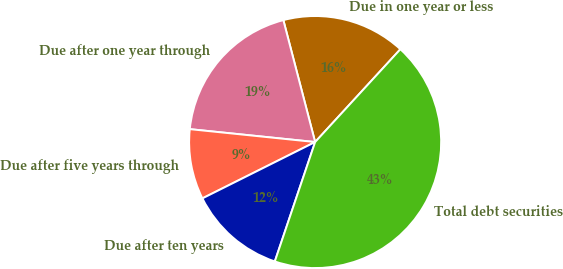Convert chart. <chart><loc_0><loc_0><loc_500><loc_500><pie_chart><fcel>Due in one year or less<fcel>Due after one year through<fcel>Due after five years through<fcel>Due after ten years<fcel>Total debt securities<nl><fcel>15.88%<fcel>19.31%<fcel>9.01%<fcel>12.44%<fcel>43.36%<nl></chart> 